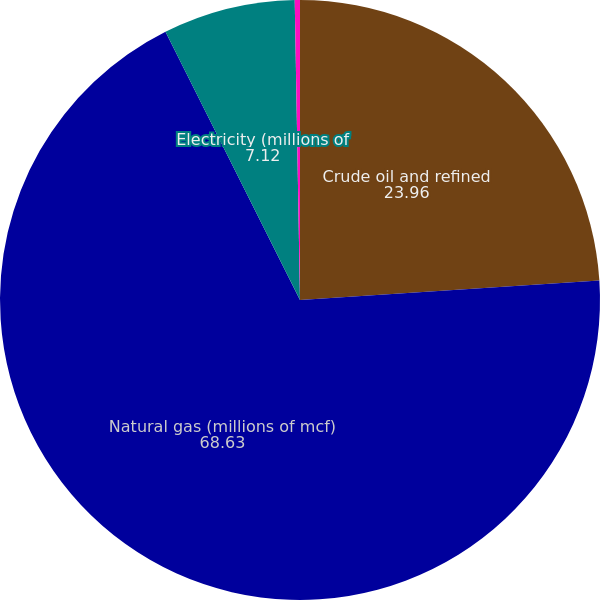<chart> <loc_0><loc_0><loc_500><loc_500><pie_chart><fcel>Crude oil and refined<fcel>Natural gas (millions of mcf)<fcel>Electricity (millions of<fcel>Equity securities (millions of<nl><fcel>23.96%<fcel>68.63%<fcel>7.12%<fcel>0.28%<nl></chart> 